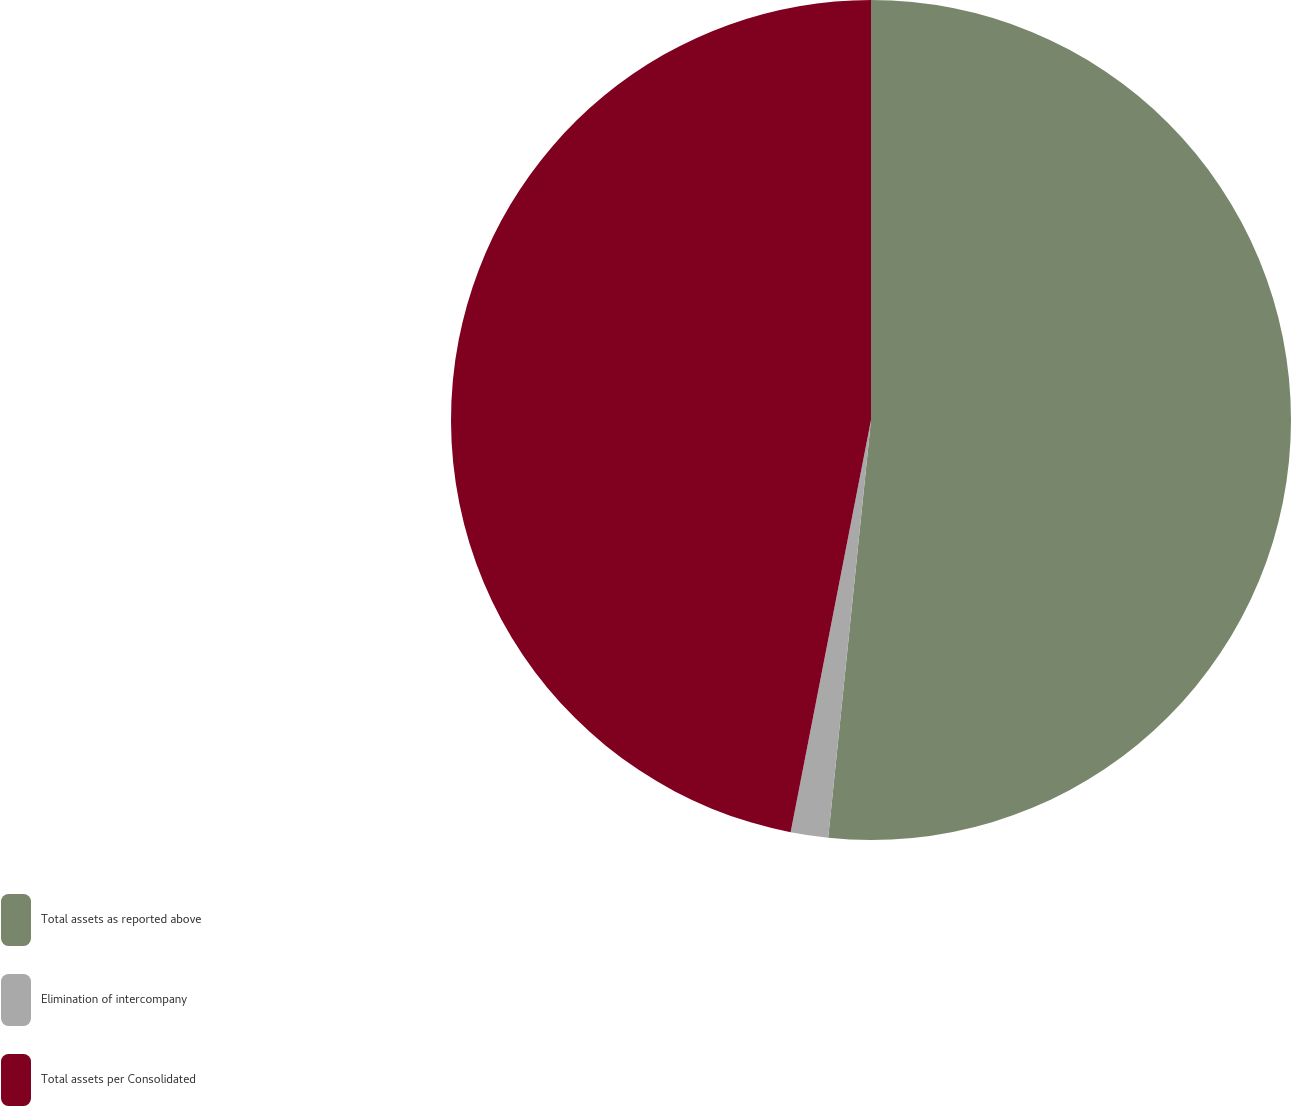Convert chart to OTSL. <chart><loc_0><loc_0><loc_500><loc_500><pie_chart><fcel>Total assets as reported above<fcel>Elimination of intercompany<fcel>Total assets per Consolidated<nl><fcel>51.63%<fcel>1.44%<fcel>46.94%<nl></chart> 